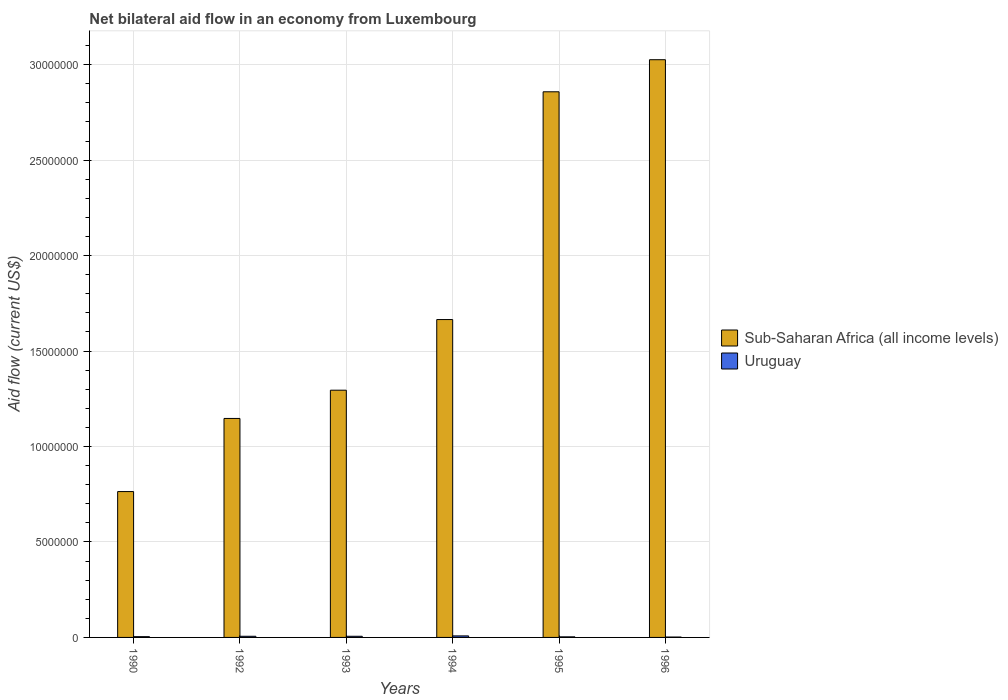How many different coloured bars are there?
Keep it short and to the point. 2. Are the number of bars per tick equal to the number of legend labels?
Keep it short and to the point. Yes. Are the number of bars on each tick of the X-axis equal?
Keep it short and to the point. Yes. How many bars are there on the 1st tick from the left?
Keep it short and to the point. 2. How many bars are there on the 5th tick from the right?
Offer a very short reply. 2. What is the label of the 6th group of bars from the left?
Give a very brief answer. 1996. In how many cases, is the number of bars for a given year not equal to the number of legend labels?
Your answer should be compact. 0. What is the net bilateral aid flow in Sub-Saharan Africa (all income levels) in 1993?
Keep it short and to the point. 1.30e+07. Across all years, what is the minimum net bilateral aid flow in Uruguay?
Your response must be concise. 2.00e+04. In which year was the net bilateral aid flow in Sub-Saharan Africa (all income levels) maximum?
Give a very brief answer. 1996. What is the total net bilateral aid flow in Uruguay in the graph?
Provide a short and direct response. 2.90e+05. What is the difference between the net bilateral aid flow in Sub-Saharan Africa (all income levels) in 1992 and that in 1994?
Your response must be concise. -5.18e+06. What is the difference between the net bilateral aid flow in Uruguay in 1994 and the net bilateral aid flow in Sub-Saharan Africa (all income levels) in 1990?
Offer a terse response. -7.56e+06. What is the average net bilateral aid flow in Sub-Saharan Africa (all income levels) per year?
Give a very brief answer. 1.79e+07. In the year 1996, what is the difference between the net bilateral aid flow in Uruguay and net bilateral aid flow in Sub-Saharan Africa (all income levels)?
Your response must be concise. -3.02e+07. What is the ratio of the net bilateral aid flow in Uruguay in 1990 to that in 1993?
Your answer should be compact. 0.67. Is the net bilateral aid flow in Uruguay in 1993 less than that in 1995?
Make the answer very short. No. Is the difference between the net bilateral aid flow in Uruguay in 1990 and 1995 greater than the difference between the net bilateral aid flow in Sub-Saharan Africa (all income levels) in 1990 and 1995?
Your answer should be very brief. Yes. What is the difference between the highest and the lowest net bilateral aid flow in Uruguay?
Your response must be concise. 6.00e+04. In how many years, is the net bilateral aid flow in Uruguay greater than the average net bilateral aid flow in Uruguay taken over all years?
Provide a succinct answer. 3. Is the sum of the net bilateral aid flow in Sub-Saharan Africa (all income levels) in 1990 and 1996 greater than the maximum net bilateral aid flow in Uruguay across all years?
Give a very brief answer. Yes. What does the 1st bar from the left in 1995 represents?
Make the answer very short. Sub-Saharan Africa (all income levels). What does the 2nd bar from the right in 1995 represents?
Offer a very short reply. Sub-Saharan Africa (all income levels). Are all the bars in the graph horizontal?
Give a very brief answer. No. Does the graph contain any zero values?
Give a very brief answer. No. How are the legend labels stacked?
Keep it short and to the point. Vertical. What is the title of the graph?
Offer a very short reply. Net bilateral aid flow in an economy from Luxembourg. What is the label or title of the X-axis?
Provide a short and direct response. Years. What is the Aid flow (current US$) in Sub-Saharan Africa (all income levels) in 1990?
Give a very brief answer. 7.64e+06. What is the Aid flow (current US$) in Sub-Saharan Africa (all income levels) in 1992?
Offer a terse response. 1.15e+07. What is the Aid flow (current US$) in Uruguay in 1992?
Your answer should be compact. 6.00e+04. What is the Aid flow (current US$) of Sub-Saharan Africa (all income levels) in 1993?
Make the answer very short. 1.30e+07. What is the Aid flow (current US$) in Uruguay in 1993?
Your answer should be compact. 6.00e+04. What is the Aid flow (current US$) in Sub-Saharan Africa (all income levels) in 1994?
Offer a terse response. 1.66e+07. What is the Aid flow (current US$) in Sub-Saharan Africa (all income levels) in 1995?
Give a very brief answer. 2.86e+07. What is the Aid flow (current US$) of Sub-Saharan Africa (all income levels) in 1996?
Keep it short and to the point. 3.03e+07. Across all years, what is the maximum Aid flow (current US$) of Sub-Saharan Africa (all income levels)?
Provide a succinct answer. 3.03e+07. Across all years, what is the maximum Aid flow (current US$) in Uruguay?
Your response must be concise. 8.00e+04. Across all years, what is the minimum Aid flow (current US$) in Sub-Saharan Africa (all income levels)?
Your response must be concise. 7.64e+06. What is the total Aid flow (current US$) of Sub-Saharan Africa (all income levels) in the graph?
Keep it short and to the point. 1.08e+08. What is the total Aid flow (current US$) in Uruguay in the graph?
Your answer should be very brief. 2.90e+05. What is the difference between the Aid flow (current US$) of Sub-Saharan Africa (all income levels) in 1990 and that in 1992?
Provide a short and direct response. -3.83e+06. What is the difference between the Aid flow (current US$) of Uruguay in 1990 and that in 1992?
Offer a very short reply. -2.00e+04. What is the difference between the Aid flow (current US$) in Sub-Saharan Africa (all income levels) in 1990 and that in 1993?
Provide a short and direct response. -5.31e+06. What is the difference between the Aid flow (current US$) of Uruguay in 1990 and that in 1993?
Ensure brevity in your answer.  -2.00e+04. What is the difference between the Aid flow (current US$) in Sub-Saharan Africa (all income levels) in 1990 and that in 1994?
Make the answer very short. -9.01e+06. What is the difference between the Aid flow (current US$) in Uruguay in 1990 and that in 1994?
Your answer should be very brief. -4.00e+04. What is the difference between the Aid flow (current US$) of Sub-Saharan Africa (all income levels) in 1990 and that in 1995?
Your response must be concise. -2.09e+07. What is the difference between the Aid flow (current US$) of Uruguay in 1990 and that in 1995?
Your answer should be compact. 10000. What is the difference between the Aid flow (current US$) in Sub-Saharan Africa (all income levels) in 1990 and that in 1996?
Keep it short and to the point. -2.26e+07. What is the difference between the Aid flow (current US$) in Sub-Saharan Africa (all income levels) in 1992 and that in 1993?
Keep it short and to the point. -1.48e+06. What is the difference between the Aid flow (current US$) of Sub-Saharan Africa (all income levels) in 1992 and that in 1994?
Offer a terse response. -5.18e+06. What is the difference between the Aid flow (current US$) in Uruguay in 1992 and that in 1994?
Make the answer very short. -2.00e+04. What is the difference between the Aid flow (current US$) of Sub-Saharan Africa (all income levels) in 1992 and that in 1995?
Provide a succinct answer. -1.71e+07. What is the difference between the Aid flow (current US$) in Sub-Saharan Africa (all income levels) in 1992 and that in 1996?
Provide a short and direct response. -1.88e+07. What is the difference between the Aid flow (current US$) of Sub-Saharan Africa (all income levels) in 1993 and that in 1994?
Make the answer very short. -3.70e+06. What is the difference between the Aid flow (current US$) of Uruguay in 1993 and that in 1994?
Ensure brevity in your answer.  -2.00e+04. What is the difference between the Aid flow (current US$) of Sub-Saharan Africa (all income levels) in 1993 and that in 1995?
Ensure brevity in your answer.  -1.56e+07. What is the difference between the Aid flow (current US$) of Sub-Saharan Africa (all income levels) in 1993 and that in 1996?
Give a very brief answer. -1.73e+07. What is the difference between the Aid flow (current US$) of Sub-Saharan Africa (all income levels) in 1994 and that in 1995?
Provide a short and direct response. -1.19e+07. What is the difference between the Aid flow (current US$) in Uruguay in 1994 and that in 1995?
Your answer should be compact. 5.00e+04. What is the difference between the Aid flow (current US$) in Sub-Saharan Africa (all income levels) in 1994 and that in 1996?
Keep it short and to the point. -1.36e+07. What is the difference between the Aid flow (current US$) of Uruguay in 1994 and that in 1996?
Provide a short and direct response. 6.00e+04. What is the difference between the Aid flow (current US$) in Sub-Saharan Africa (all income levels) in 1995 and that in 1996?
Your response must be concise. -1.68e+06. What is the difference between the Aid flow (current US$) of Sub-Saharan Africa (all income levels) in 1990 and the Aid flow (current US$) of Uruguay in 1992?
Ensure brevity in your answer.  7.58e+06. What is the difference between the Aid flow (current US$) of Sub-Saharan Africa (all income levels) in 1990 and the Aid flow (current US$) of Uruguay in 1993?
Keep it short and to the point. 7.58e+06. What is the difference between the Aid flow (current US$) of Sub-Saharan Africa (all income levels) in 1990 and the Aid flow (current US$) of Uruguay in 1994?
Offer a terse response. 7.56e+06. What is the difference between the Aid flow (current US$) in Sub-Saharan Africa (all income levels) in 1990 and the Aid flow (current US$) in Uruguay in 1995?
Your answer should be very brief. 7.61e+06. What is the difference between the Aid flow (current US$) in Sub-Saharan Africa (all income levels) in 1990 and the Aid flow (current US$) in Uruguay in 1996?
Your answer should be compact. 7.62e+06. What is the difference between the Aid flow (current US$) of Sub-Saharan Africa (all income levels) in 1992 and the Aid flow (current US$) of Uruguay in 1993?
Your response must be concise. 1.14e+07. What is the difference between the Aid flow (current US$) of Sub-Saharan Africa (all income levels) in 1992 and the Aid flow (current US$) of Uruguay in 1994?
Offer a terse response. 1.14e+07. What is the difference between the Aid flow (current US$) in Sub-Saharan Africa (all income levels) in 1992 and the Aid flow (current US$) in Uruguay in 1995?
Your answer should be very brief. 1.14e+07. What is the difference between the Aid flow (current US$) of Sub-Saharan Africa (all income levels) in 1992 and the Aid flow (current US$) of Uruguay in 1996?
Your answer should be very brief. 1.14e+07. What is the difference between the Aid flow (current US$) in Sub-Saharan Africa (all income levels) in 1993 and the Aid flow (current US$) in Uruguay in 1994?
Provide a short and direct response. 1.29e+07. What is the difference between the Aid flow (current US$) of Sub-Saharan Africa (all income levels) in 1993 and the Aid flow (current US$) of Uruguay in 1995?
Your answer should be compact. 1.29e+07. What is the difference between the Aid flow (current US$) of Sub-Saharan Africa (all income levels) in 1993 and the Aid flow (current US$) of Uruguay in 1996?
Ensure brevity in your answer.  1.29e+07. What is the difference between the Aid flow (current US$) of Sub-Saharan Africa (all income levels) in 1994 and the Aid flow (current US$) of Uruguay in 1995?
Provide a short and direct response. 1.66e+07. What is the difference between the Aid flow (current US$) of Sub-Saharan Africa (all income levels) in 1994 and the Aid flow (current US$) of Uruguay in 1996?
Keep it short and to the point. 1.66e+07. What is the difference between the Aid flow (current US$) of Sub-Saharan Africa (all income levels) in 1995 and the Aid flow (current US$) of Uruguay in 1996?
Provide a succinct answer. 2.86e+07. What is the average Aid flow (current US$) of Sub-Saharan Africa (all income levels) per year?
Offer a very short reply. 1.79e+07. What is the average Aid flow (current US$) in Uruguay per year?
Your answer should be compact. 4.83e+04. In the year 1990, what is the difference between the Aid flow (current US$) of Sub-Saharan Africa (all income levels) and Aid flow (current US$) of Uruguay?
Provide a short and direct response. 7.60e+06. In the year 1992, what is the difference between the Aid flow (current US$) of Sub-Saharan Africa (all income levels) and Aid flow (current US$) of Uruguay?
Keep it short and to the point. 1.14e+07. In the year 1993, what is the difference between the Aid flow (current US$) of Sub-Saharan Africa (all income levels) and Aid flow (current US$) of Uruguay?
Give a very brief answer. 1.29e+07. In the year 1994, what is the difference between the Aid flow (current US$) of Sub-Saharan Africa (all income levels) and Aid flow (current US$) of Uruguay?
Offer a very short reply. 1.66e+07. In the year 1995, what is the difference between the Aid flow (current US$) in Sub-Saharan Africa (all income levels) and Aid flow (current US$) in Uruguay?
Provide a succinct answer. 2.86e+07. In the year 1996, what is the difference between the Aid flow (current US$) in Sub-Saharan Africa (all income levels) and Aid flow (current US$) in Uruguay?
Your answer should be compact. 3.02e+07. What is the ratio of the Aid flow (current US$) in Sub-Saharan Africa (all income levels) in 1990 to that in 1992?
Offer a terse response. 0.67. What is the ratio of the Aid flow (current US$) of Sub-Saharan Africa (all income levels) in 1990 to that in 1993?
Give a very brief answer. 0.59. What is the ratio of the Aid flow (current US$) of Uruguay in 1990 to that in 1993?
Offer a terse response. 0.67. What is the ratio of the Aid flow (current US$) in Sub-Saharan Africa (all income levels) in 1990 to that in 1994?
Give a very brief answer. 0.46. What is the ratio of the Aid flow (current US$) in Sub-Saharan Africa (all income levels) in 1990 to that in 1995?
Give a very brief answer. 0.27. What is the ratio of the Aid flow (current US$) in Sub-Saharan Africa (all income levels) in 1990 to that in 1996?
Provide a short and direct response. 0.25. What is the ratio of the Aid flow (current US$) of Uruguay in 1990 to that in 1996?
Offer a terse response. 2. What is the ratio of the Aid flow (current US$) in Sub-Saharan Africa (all income levels) in 1992 to that in 1993?
Ensure brevity in your answer.  0.89. What is the ratio of the Aid flow (current US$) of Uruguay in 1992 to that in 1993?
Keep it short and to the point. 1. What is the ratio of the Aid flow (current US$) of Sub-Saharan Africa (all income levels) in 1992 to that in 1994?
Your answer should be compact. 0.69. What is the ratio of the Aid flow (current US$) in Sub-Saharan Africa (all income levels) in 1992 to that in 1995?
Provide a short and direct response. 0.4. What is the ratio of the Aid flow (current US$) of Uruguay in 1992 to that in 1995?
Ensure brevity in your answer.  2. What is the ratio of the Aid flow (current US$) of Sub-Saharan Africa (all income levels) in 1992 to that in 1996?
Keep it short and to the point. 0.38. What is the ratio of the Aid flow (current US$) in Sub-Saharan Africa (all income levels) in 1993 to that in 1994?
Offer a terse response. 0.78. What is the ratio of the Aid flow (current US$) of Sub-Saharan Africa (all income levels) in 1993 to that in 1995?
Your answer should be compact. 0.45. What is the ratio of the Aid flow (current US$) of Sub-Saharan Africa (all income levels) in 1993 to that in 1996?
Ensure brevity in your answer.  0.43. What is the ratio of the Aid flow (current US$) in Uruguay in 1993 to that in 1996?
Your answer should be very brief. 3. What is the ratio of the Aid flow (current US$) of Sub-Saharan Africa (all income levels) in 1994 to that in 1995?
Give a very brief answer. 0.58. What is the ratio of the Aid flow (current US$) in Uruguay in 1994 to that in 1995?
Provide a short and direct response. 2.67. What is the ratio of the Aid flow (current US$) of Sub-Saharan Africa (all income levels) in 1994 to that in 1996?
Your answer should be very brief. 0.55. What is the ratio of the Aid flow (current US$) in Uruguay in 1994 to that in 1996?
Give a very brief answer. 4. What is the ratio of the Aid flow (current US$) in Sub-Saharan Africa (all income levels) in 1995 to that in 1996?
Make the answer very short. 0.94. What is the ratio of the Aid flow (current US$) in Uruguay in 1995 to that in 1996?
Make the answer very short. 1.5. What is the difference between the highest and the second highest Aid flow (current US$) of Sub-Saharan Africa (all income levels)?
Provide a succinct answer. 1.68e+06. What is the difference between the highest and the second highest Aid flow (current US$) in Uruguay?
Make the answer very short. 2.00e+04. What is the difference between the highest and the lowest Aid flow (current US$) of Sub-Saharan Africa (all income levels)?
Your answer should be very brief. 2.26e+07. What is the difference between the highest and the lowest Aid flow (current US$) of Uruguay?
Make the answer very short. 6.00e+04. 